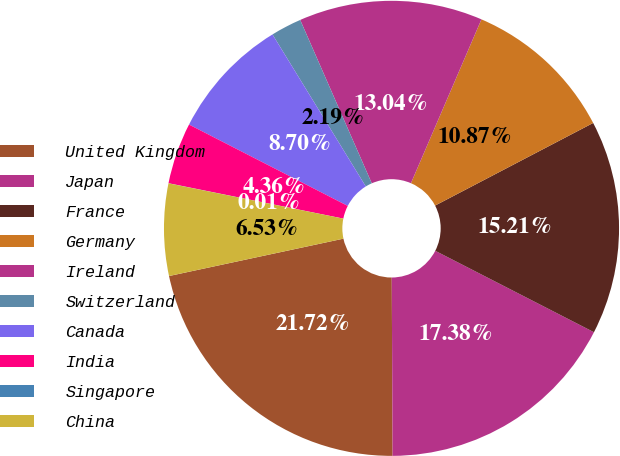Convert chart to OTSL. <chart><loc_0><loc_0><loc_500><loc_500><pie_chart><fcel>United Kingdom<fcel>Japan<fcel>France<fcel>Germany<fcel>Ireland<fcel>Switzerland<fcel>Canada<fcel>India<fcel>Singapore<fcel>China<nl><fcel>21.72%<fcel>17.38%<fcel>15.21%<fcel>10.87%<fcel>13.04%<fcel>2.19%<fcel>8.7%<fcel>4.36%<fcel>0.01%<fcel>6.53%<nl></chart> 